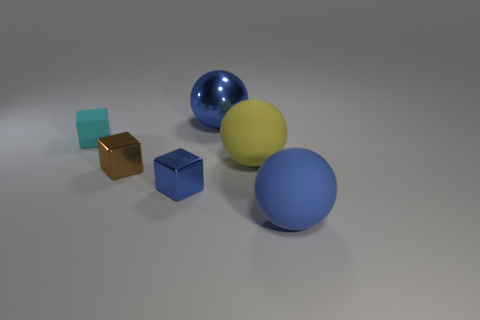What color is the matte sphere that is to the right of the large yellow sphere? blue 